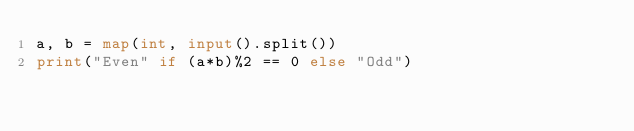<code> <loc_0><loc_0><loc_500><loc_500><_Python_>a, b = map(int, input().split())
print("Even" if (a*b)%2 == 0 else "Odd")
</code> 